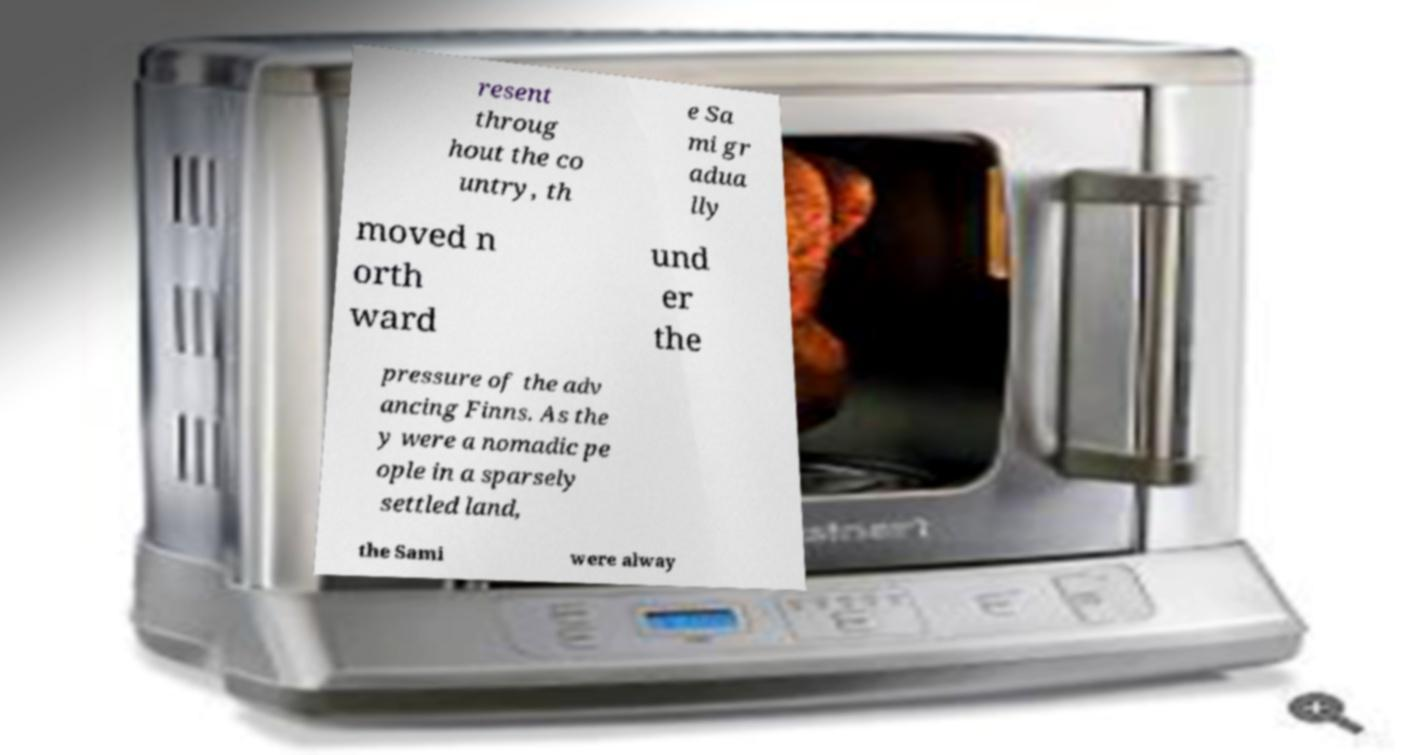Could you assist in decoding the text presented in this image and type it out clearly? resent throug hout the co untry, th e Sa mi gr adua lly moved n orth ward und er the pressure of the adv ancing Finns. As the y were a nomadic pe ople in a sparsely settled land, the Sami were alway 